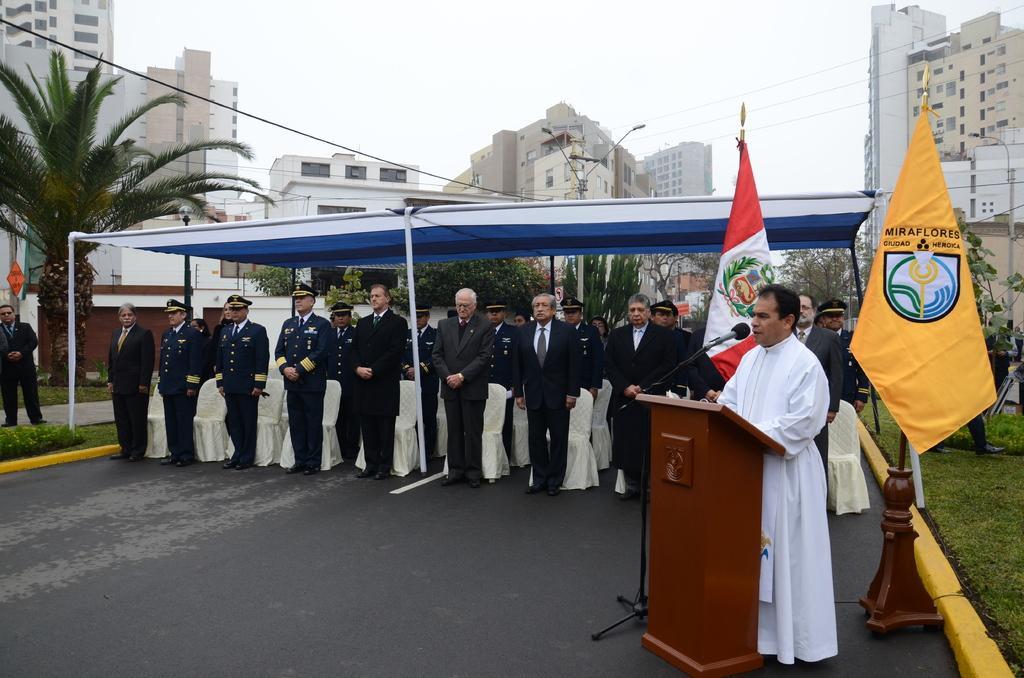In one or two sentences, can you explain what this image depicts? There are groups of people standing. These are the flags hanging to the poles. This is a wooden podium. I can see a mike with a mike stand. These are the buildings with the windows. I can see the grass. These are the trees. This looks like a street light. This is the sky. I think this is a kind of a tent. At the bottom of the image, I can see the road. 